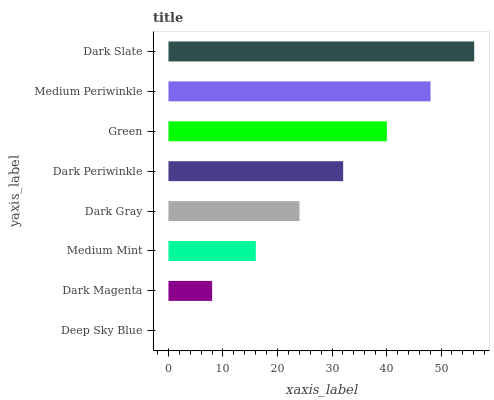Is Deep Sky Blue the minimum?
Answer yes or no. Yes. Is Dark Slate the maximum?
Answer yes or no. Yes. Is Dark Magenta the minimum?
Answer yes or no. No. Is Dark Magenta the maximum?
Answer yes or no. No. Is Dark Magenta greater than Deep Sky Blue?
Answer yes or no. Yes. Is Deep Sky Blue less than Dark Magenta?
Answer yes or no. Yes. Is Deep Sky Blue greater than Dark Magenta?
Answer yes or no. No. Is Dark Magenta less than Deep Sky Blue?
Answer yes or no. No. Is Dark Periwinkle the high median?
Answer yes or no. Yes. Is Dark Gray the low median?
Answer yes or no. Yes. Is Medium Periwinkle the high median?
Answer yes or no. No. Is Dark Slate the low median?
Answer yes or no. No. 